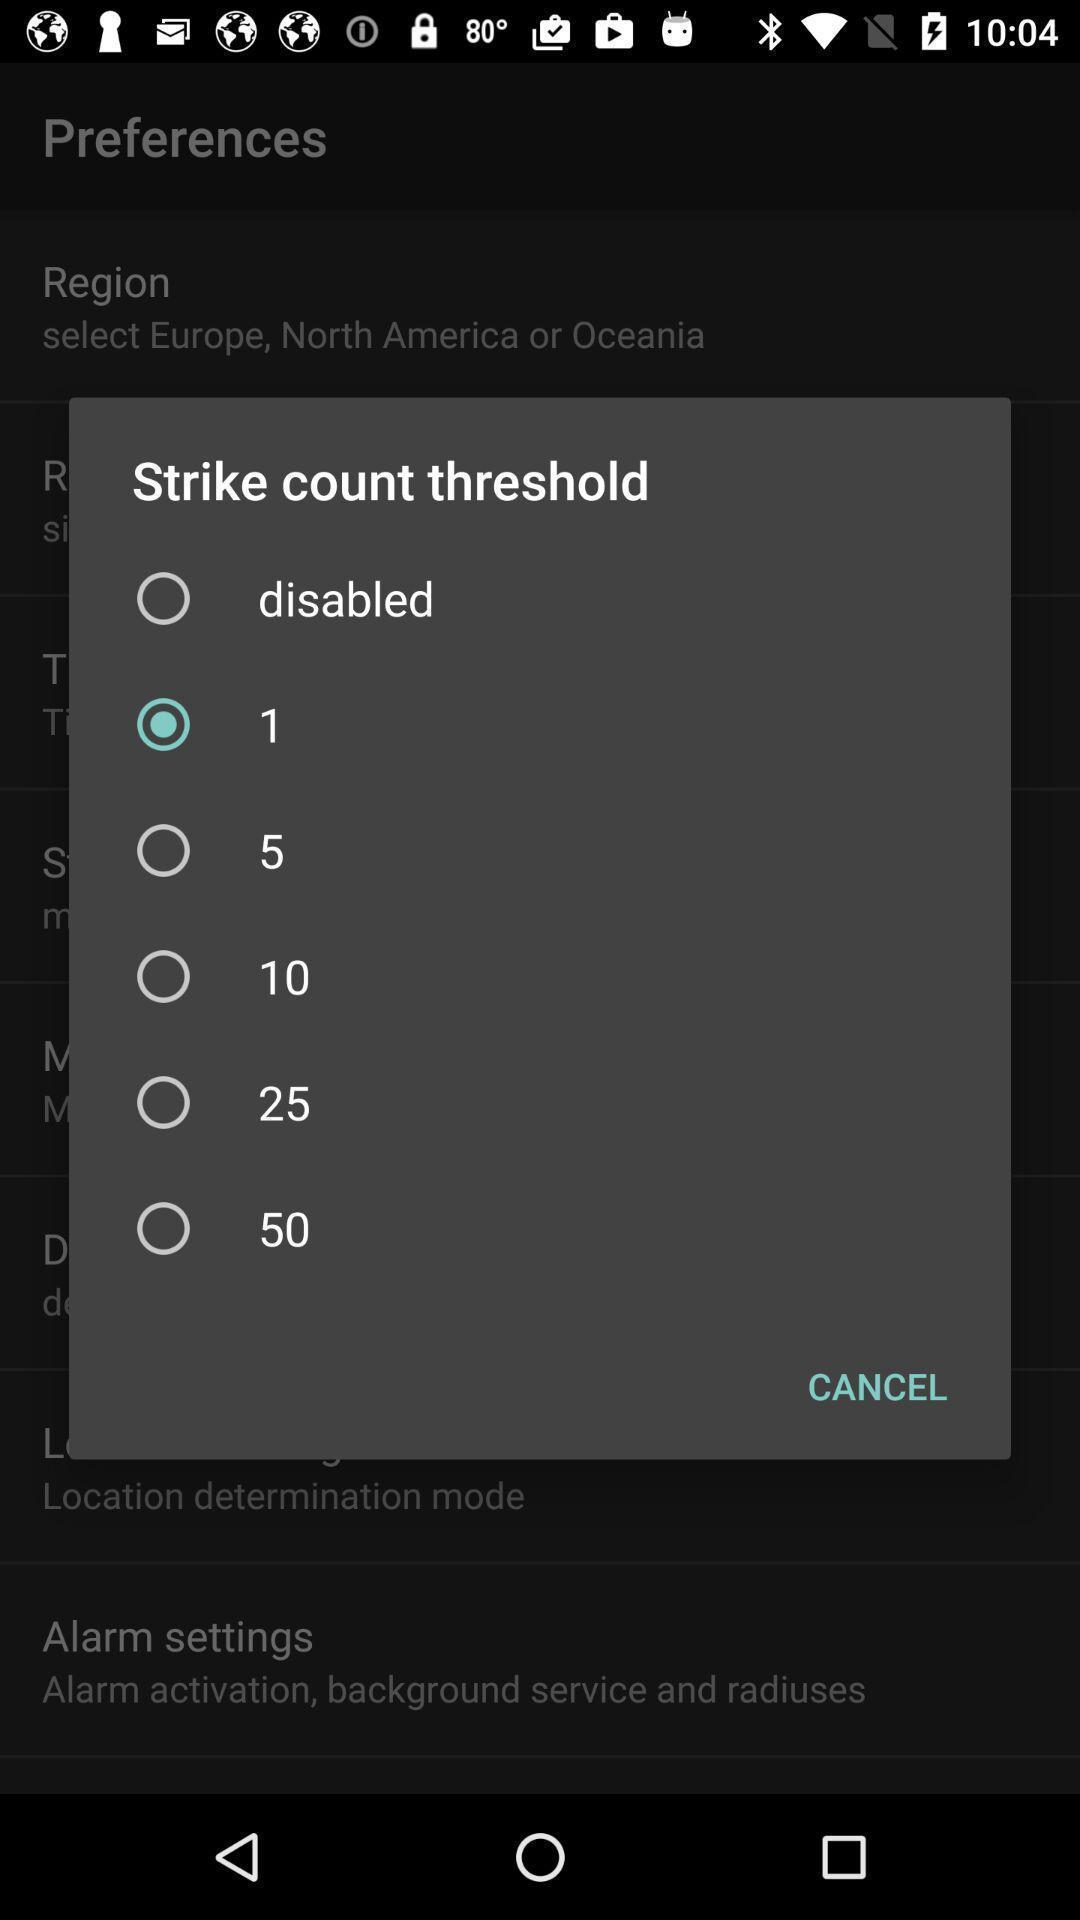What can you discern from this picture? Pop-up shows to select strike count threshold. 